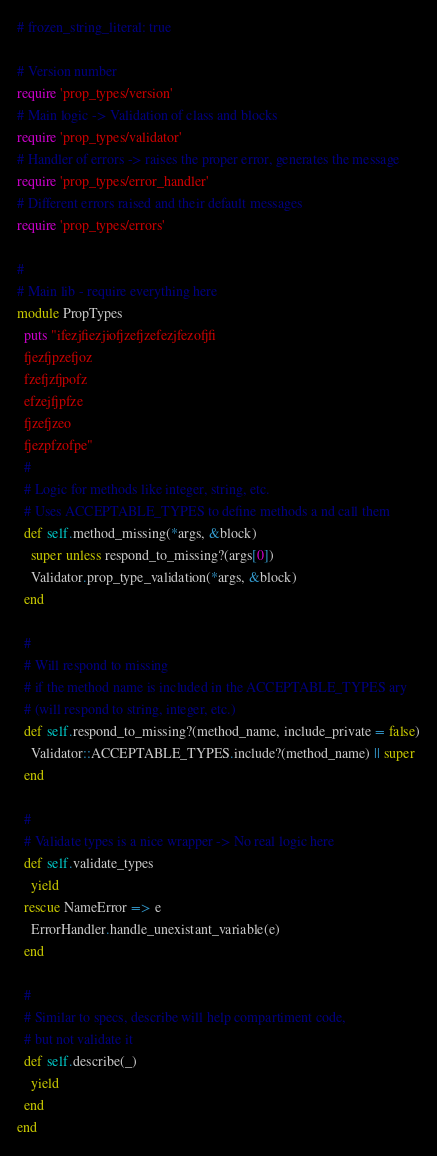<code> <loc_0><loc_0><loc_500><loc_500><_Ruby_># frozen_string_literal: true

# Version number
require 'prop_types/version'
# Main logic -> Validation of class and blocks
require 'prop_types/validator'
# Handler of errors -> raises the proper error, generates the message
require 'prop_types/error_handler'
# Different errors raised and their default messages
require 'prop_types/errors'

#
# Main lib - require everything here
module PropTypes
  puts "ifezjfiezjiofjzefjzefezjfezofjfi
  fjezfjpzefjoz
  fzefjzfjpofz
  efzejfjpfze
  fjzefjzeo
  fjezpfzofpe"
  #
  # Logic for methods like integer, string, etc.
  # Uses ACCEPTABLE_TYPES to define methods a nd call them
  def self.method_missing(*args, &block)
    super unless respond_to_missing?(args[0])
    Validator.prop_type_validation(*args, &block)
  end

  #
  # Will respond to missing
  # if the method name is included in the ACCEPTABLE_TYPES ary
  # (will respond to string, integer, etc.)
  def self.respond_to_missing?(method_name, include_private = false)
    Validator::ACCEPTABLE_TYPES.include?(method_name) || super
  end

  #
  # Validate types is a nice wrapper -> No real logic here
  def self.validate_types
    yield
  rescue NameError => e
    ErrorHandler.handle_unexistant_variable(e)
  end

  #
  # Similar to specs, describe will help compartiment code,
  # but not validate it
  def self.describe(_)
    yield
  end
end
</code> 